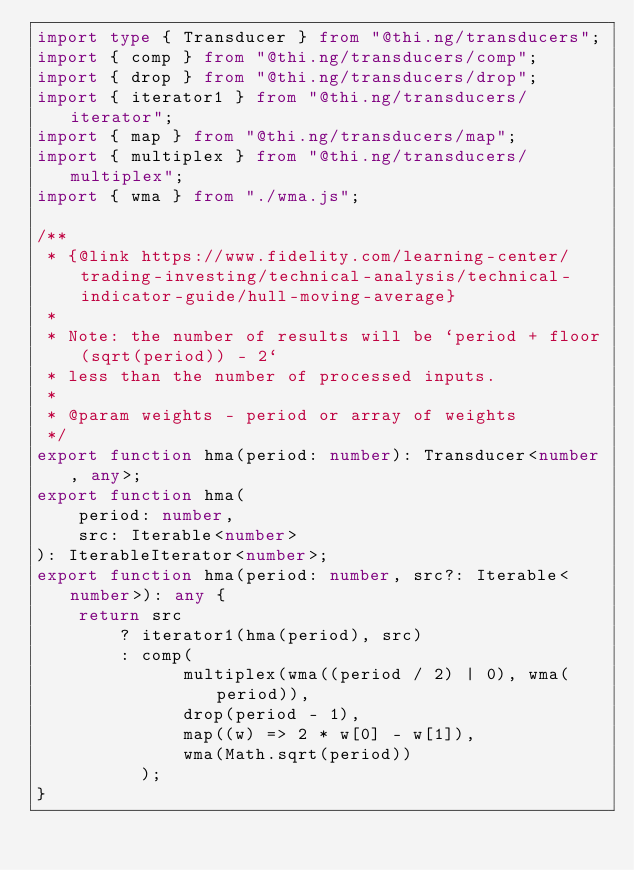Convert code to text. <code><loc_0><loc_0><loc_500><loc_500><_TypeScript_>import type { Transducer } from "@thi.ng/transducers";
import { comp } from "@thi.ng/transducers/comp";
import { drop } from "@thi.ng/transducers/drop";
import { iterator1 } from "@thi.ng/transducers/iterator";
import { map } from "@thi.ng/transducers/map";
import { multiplex } from "@thi.ng/transducers/multiplex";
import { wma } from "./wma.js";

/**
 * {@link https://www.fidelity.com/learning-center/trading-investing/technical-analysis/technical-indicator-guide/hull-moving-average}
 *
 * Note: the number of results will be `period + floor(sqrt(period)) - 2`
 * less than the number of processed inputs.
 *
 * @param weights - period or array of weights
 */
export function hma(period: number): Transducer<number, any>;
export function hma(
    period: number,
    src: Iterable<number>
): IterableIterator<number>;
export function hma(period: number, src?: Iterable<number>): any {
    return src
        ? iterator1(hma(period), src)
        : comp(
              multiplex(wma((period / 2) | 0), wma(period)),
              drop(period - 1),
              map((w) => 2 * w[0] - w[1]),
              wma(Math.sqrt(period))
          );
}
</code> 